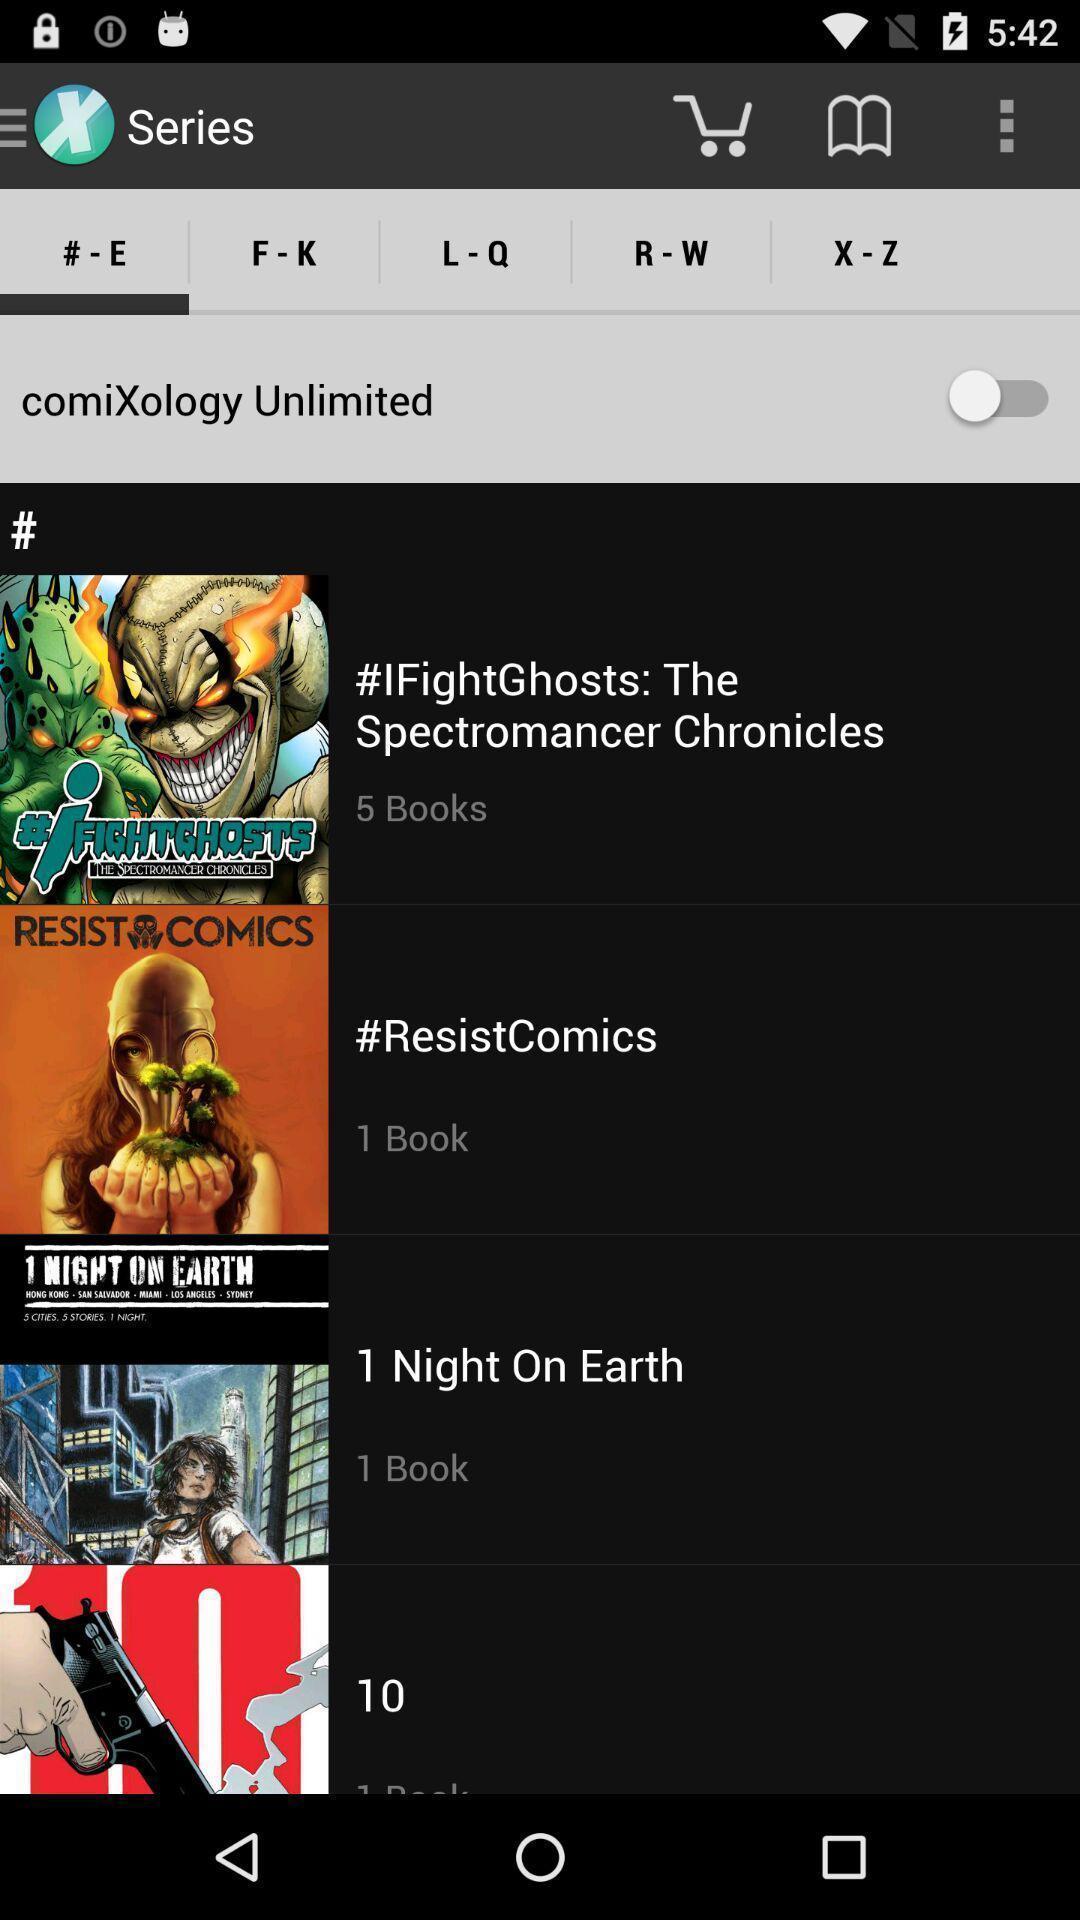Describe this image in words. Screen displaying the list of series. 